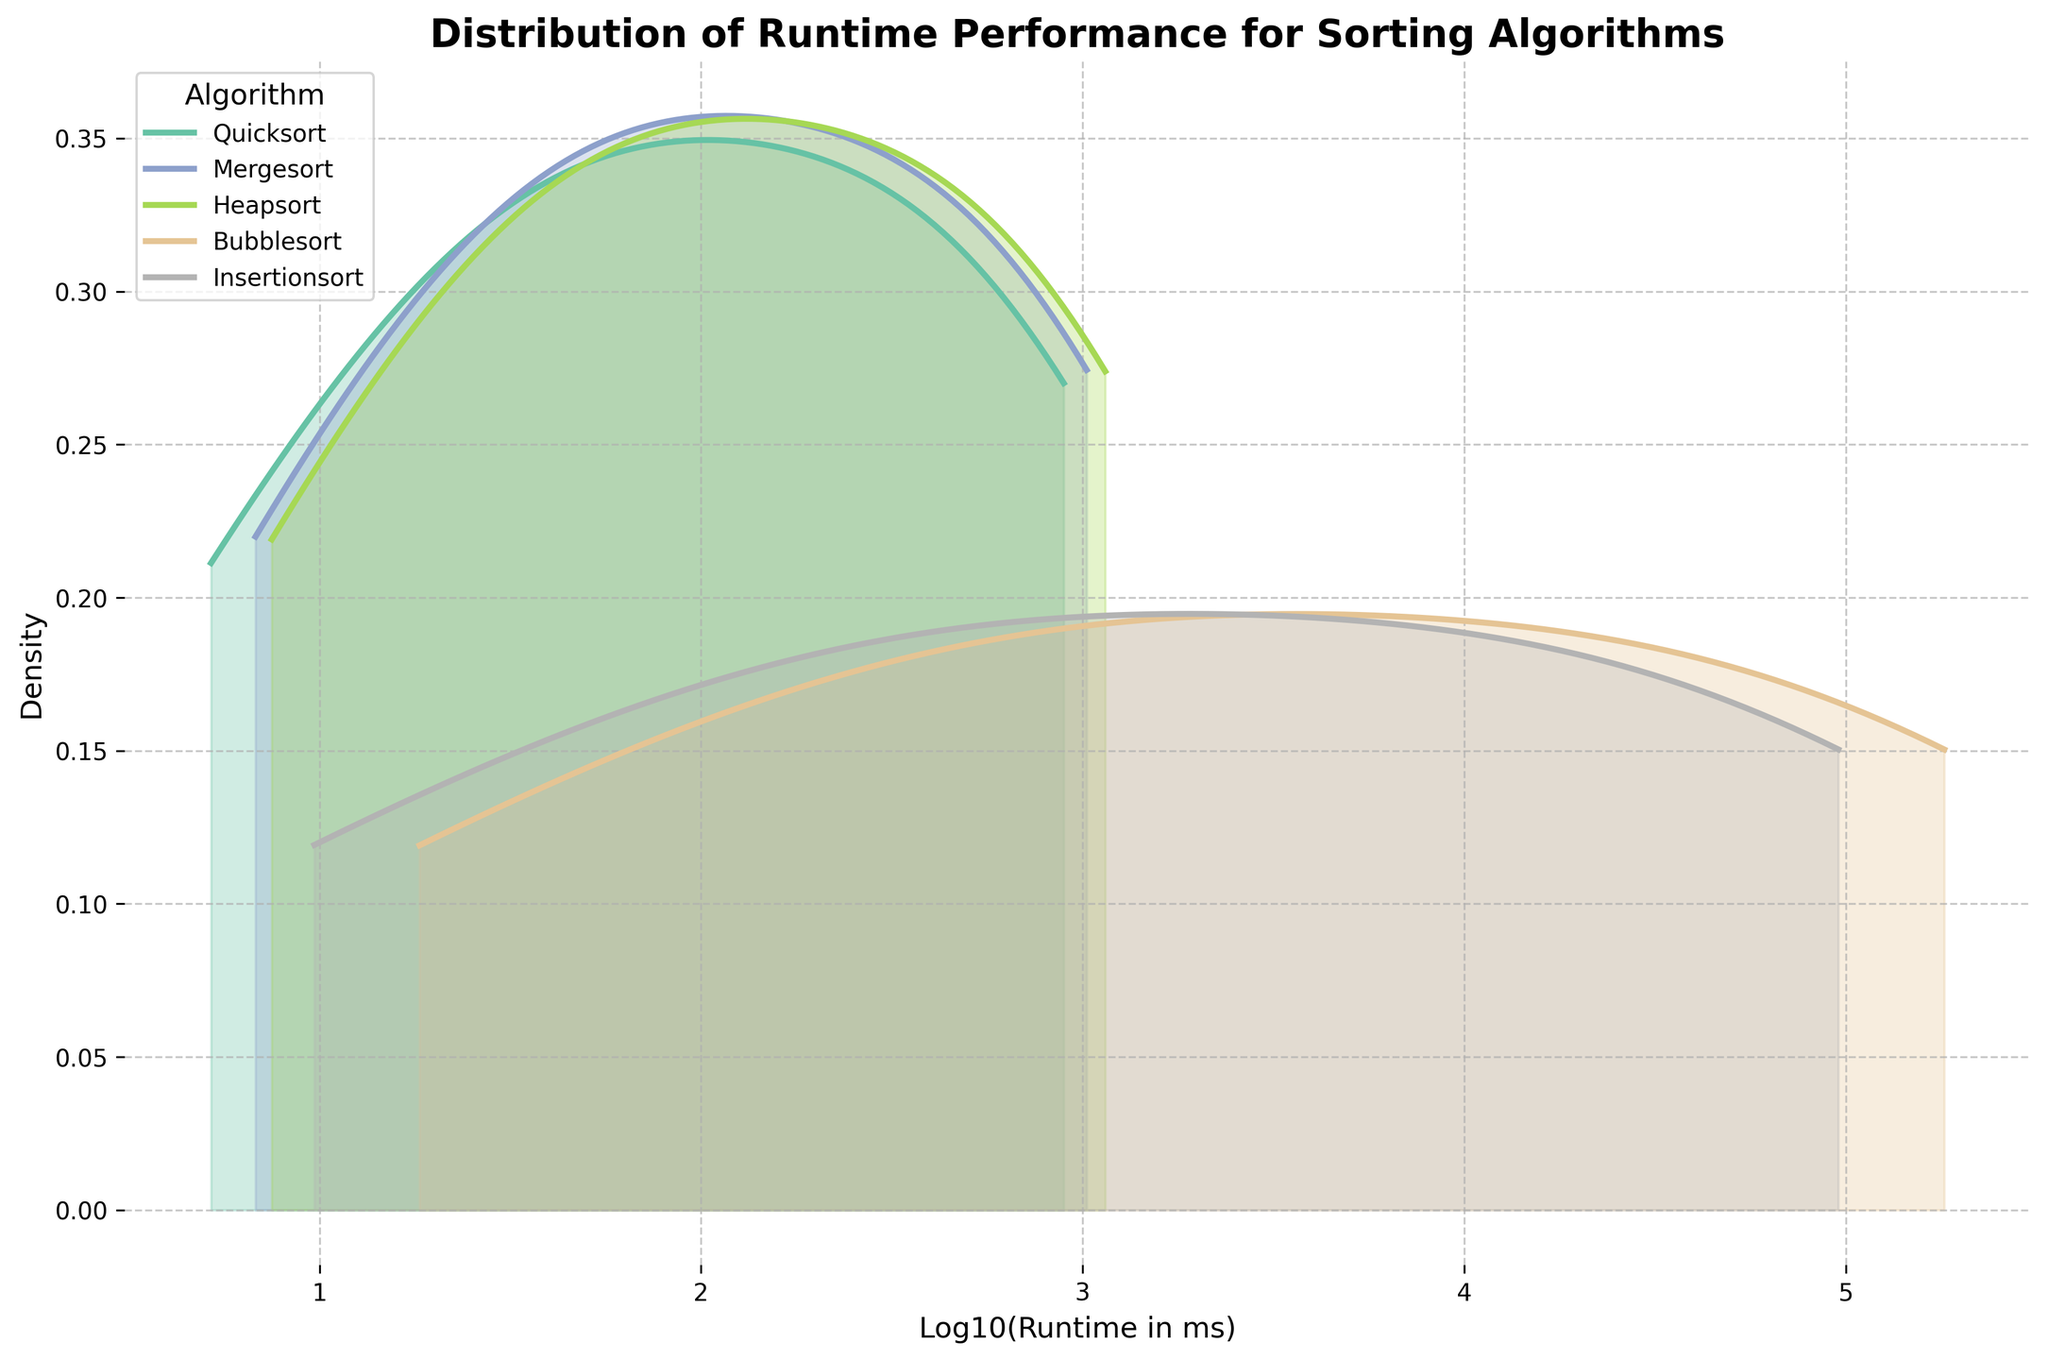What is the title of the figure? Look at the top of the plot where the title is typically placed in a larger and bold font.
Answer: Distribution of Runtime Performance for Sorting Algorithms Which axis represents the runtime of sorting algorithms? There are two axes: one horizontal and one vertical. The label on the horizontal axis mentions 'Log10(Runtime in ms)', indicating it represents the runtime.
Answer: The horizontal axis What color represents Quicksort in the density plot? Identify the label for Quicksort in the legend and then match it with the corresponding color used in the plot lines and filled area under the curves.
Answer: The specific color How do the densities for Mergesort and Quicksort compare for larger dataset sizes? Refer to the density curves and note their peak positions and the spread. Mergesort and Quicksort should have curves that we can compare visually for their runtime distributions for larger dataset sizes.
Answer: Mergesort has a broader spread than Quicksort for larger dataset sizes Which algorithm has the highest runtime distribution density peak? Look for the peak points of all curves and identify the algorithm with the highest peak.
Answer: Quicksort How does Bubblesort's density curve differ from the others? Examine the shape of Bubblesort's density curve and compare it with the shapes of the curves for other algorithms.
Answer: It has a much wider spread and lower density peaks Between Heapsort and Insertionsort, which has a higher density at lower runtime values? Focus on the left end (lower runtime values) of the density curves for both Heapsort and Insertionsort and compare their heights.
Answer: Insertionsort Are there any noticeable differences in the density distributions among the algorithms? Analyze the shapes, peaks, and spreads of the density curves to determine if there are significant visual differences.
Answer: Yes, noticeable differences are present, with each algorithm displaying unique density curve characteristics What does the horizontal axis label 'Log10(Runtime in ms)' indicate about the data transformation applied? The 'Log10' indicates a logarithmic transformation was applied to the runtime data, which compresses larger values and expands smaller values.
Answer: Logarithmic transformation What is the overall trend in the runtime distribution among the algorithms as dataset size increases? Examine how the density curves shift along the horizontal axis (log-transformed runtime) as the dataset size increases.
Answer: The overall trend shows longer runtimes as dataset size increases 